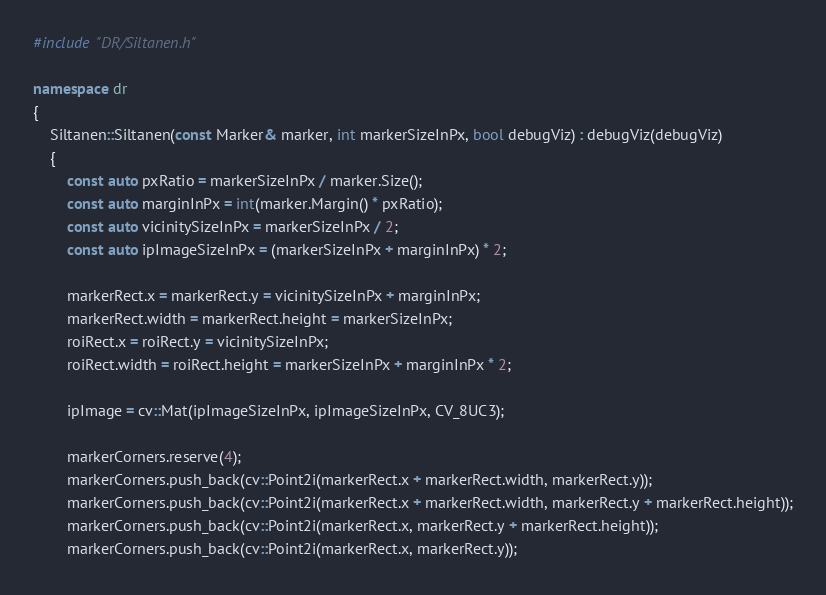Convert code to text. <code><loc_0><loc_0><loc_500><loc_500><_C++_>#include "DR/Siltanen.h"

namespace dr
{
	Siltanen::Siltanen(const Marker& marker, int markerSizeInPx, bool debugViz) : debugViz(debugViz)
	{
		const auto pxRatio = markerSizeInPx / marker.Size();
		const auto marginInPx = int(marker.Margin() * pxRatio);
		const auto vicinitySizeInPx = markerSizeInPx / 2;
		const auto ipImageSizeInPx = (markerSizeInPx + marginInPx) * 2;

		markerRect.x = markerRect.y = vicinitySizeInPx + marginInPx;
		markerRect.width = markerRect.height = markerSizeInPx;
		roiRect.x = roiRect.y = vicinitySizeInPx;
		roiRect.width = roiRect.height = markerSizeInPx + marginInPx * 2;

		ipImage = cv::Mat(ipImageSizeInPx, ipImageSizeInPx, CV_8UC3);

		markerCorners.reserve(4);
		markerCorners.push_back(cv::Point2i(markerRect.x + markerRect.width, markerRect.y));
		markerCorners.push_back(cv::Point2i(markerRect.x + markerRect.width, markerRect.y + markerRect.height));
		markerCorners.push_back(cv::Point2i(markerRect.x, markerRect.y + markerRect.height));
		markerCorners.push_back(cv::Point2i(markerRect.x, markerRect.y));
</code> 